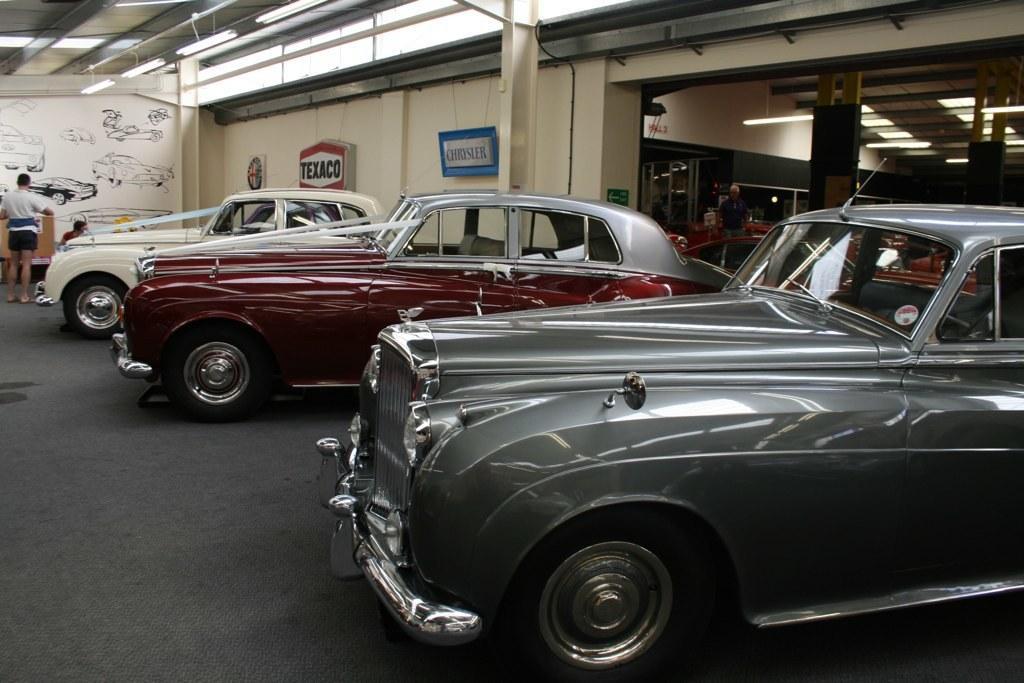Can you describe this image briefly? In this image I can see many cars, in front the car is in gray color. Background I can see the other person standing and wall is in cream color and few board hanged to the pole. 